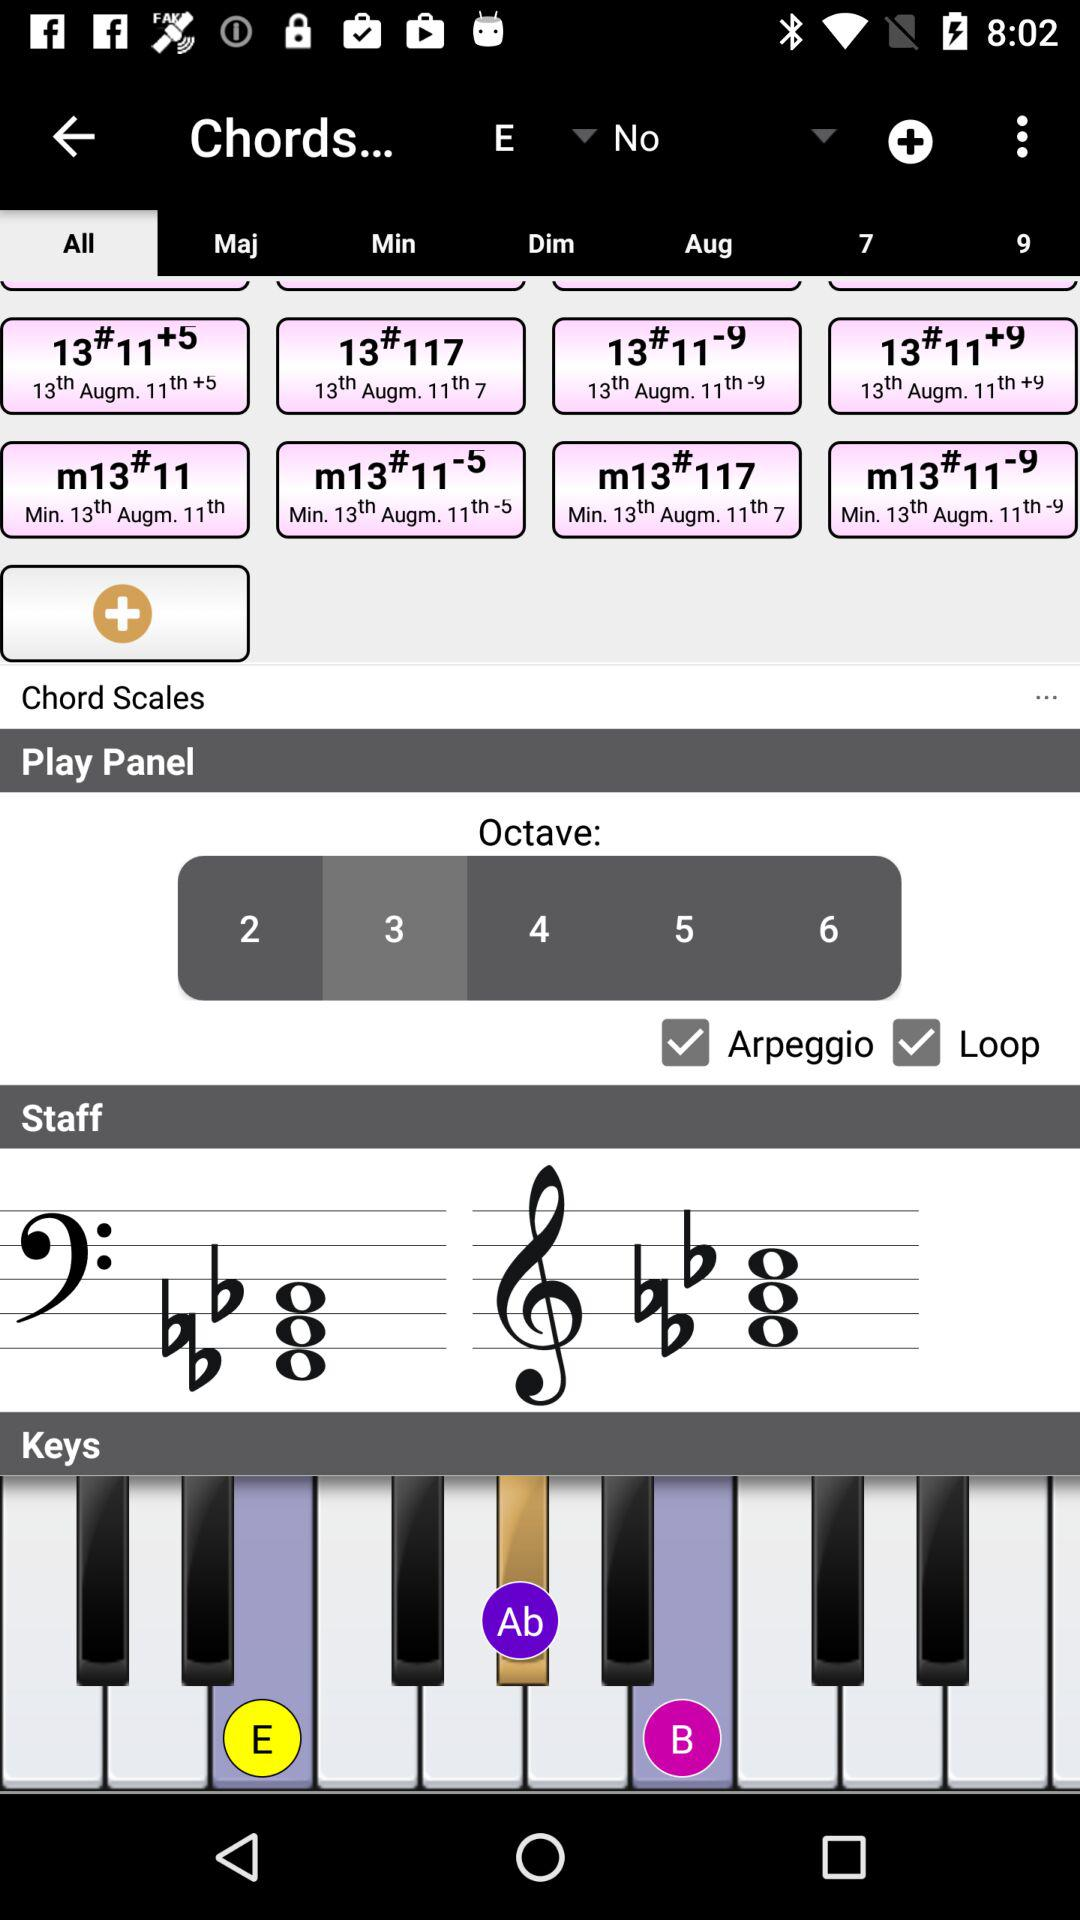What are the effects of changing the octave settings in this application? Changing the octave settings in this application alters the pitch of the notes you play. Lower octaves will produce deeper, bass-heavy sounds, while higher octaves yield sharper, higher-pitched notes, useful for melodies or higher harmonies. 